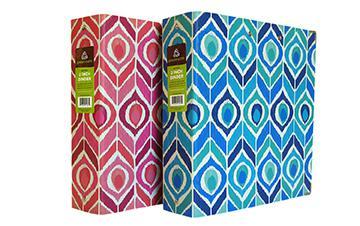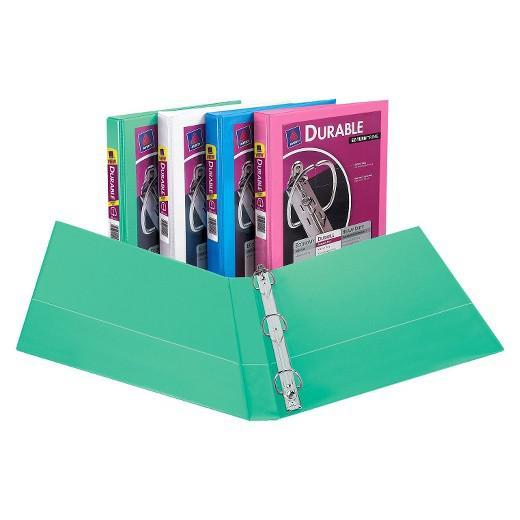The first image is the image on the left, the second image is the image on the right. For the images displayed, is the sentence "One binder is open and showing its prongs." factually correct? Answer yes or no. Yes. 